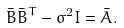<formula> <loc_0><loc_0><loc_500><loc_500>\bar { B } \bar { B } ^ { T } - \sigma ^ { 2 } I = \bar { A } .</formula> 